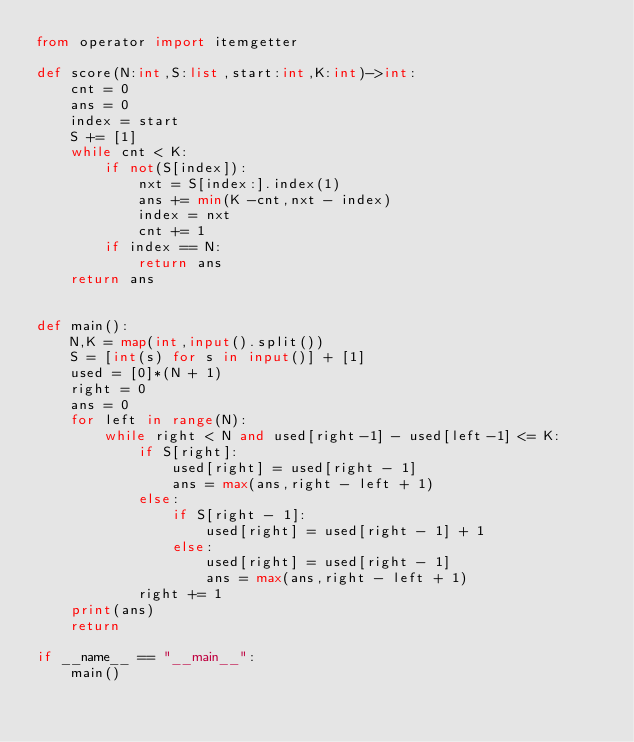Convert code to text. <code><loc_0><loc_0><loc_500><loc_500><_Python_>from operator import itemgetter

def score(N:int,S:list,start:int,K:int)->int:
    cnt = 0
    ans = 0
    index = start
    S += [1]
    while cnt < K:
        if not(S[index]):
            nxt = S[index:].index(1)
            ans += min(K -cnt,nxt - index)
            index = nxt
            cnt += 1
        if index == N:
            return ans
    return ans


def main():
    N,K = map(int,input().split())
    S = [int(s) for s in input()] + [1]
    used = [0]*(N + 1)
    right = 0
    ans = 0
    for left in range(N):
        while right < N and used[right-1] - used[left-1] <= K:
            if S[right]:
                used[right] = used[right - 1]
                ans = max(ans,right - left + 1)
            else:
                if S[right - 1]:
                    used[right] = used[right - 1] + 1
                else:
                    used[right] = used[right - 1]
                    ans = max(ans,right - left + 1)
            right += 1
    print(ans)
    return 

if __name__ == "__main__":
    main()</code> 